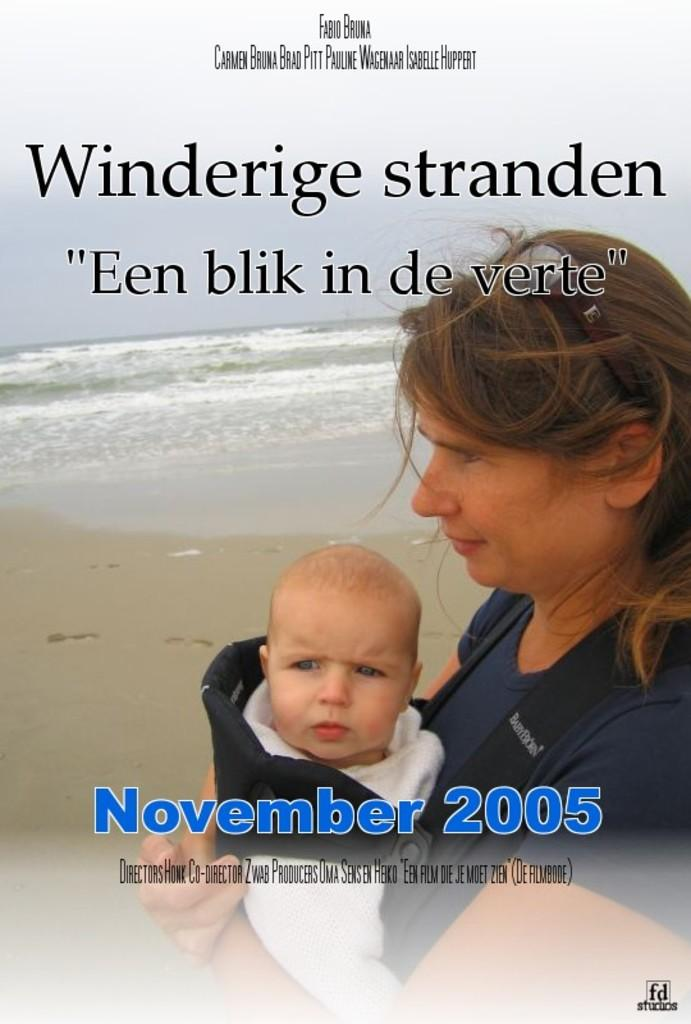What is depicted on the poster in the image? The poster features a woman holding a child. What can be seen in the background of the poster? There is a beach in the background of the poster. What type of terrain is visible at the bottom of the image? There is sand at the bottom of the image. How many ants can be seen crawling on the poster in the image? There are no ants visible on the poster in the image. What type of cover is protecting the team from the sun in the image? There is no team or cover present in the image; it features a poster with a woman holding a child and a beach background. 